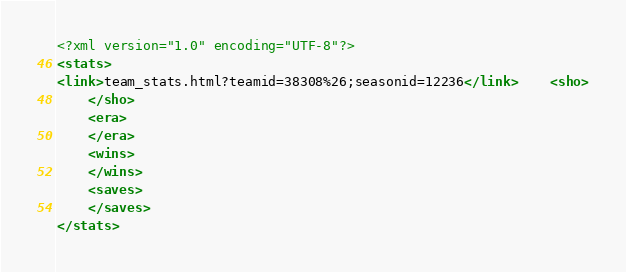Convert code to text. <code><loc_0><loc_0><loc_500><loc_500><_XML_><?xml version="1.0" encoding="UTF-8"?>
<stats>
<link>team_stats.html?teamid=38308%26;seasonid=12236</link>	<sho>
	</sho>
	<era>
	</era>
	<wins>
	</wins>
	<saves>
	</saves>
</stats>
</code> 